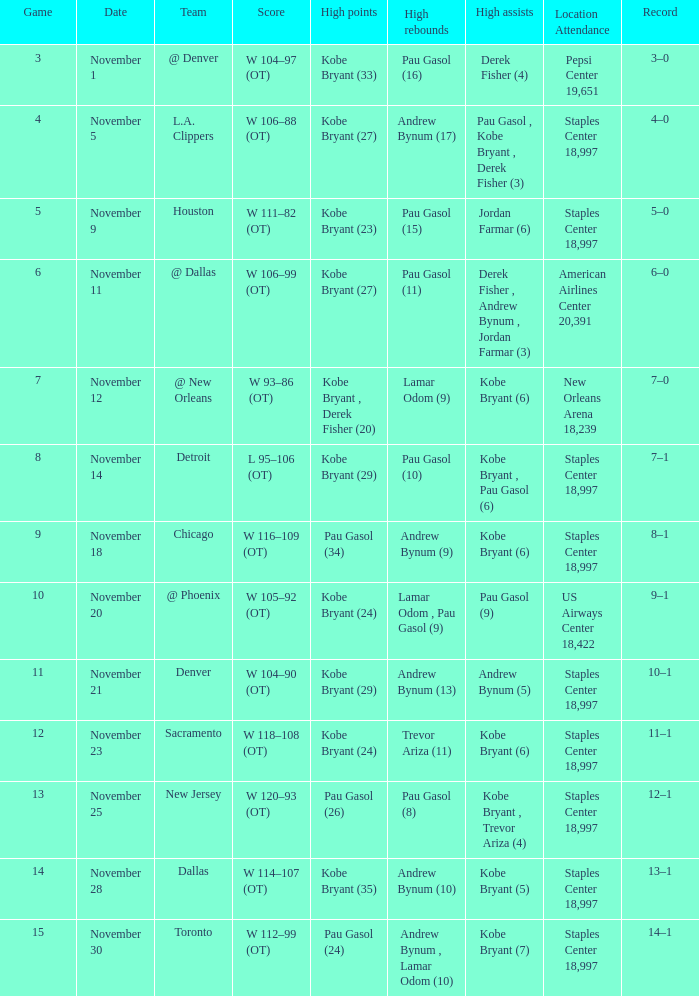What is High Assists, when High Points is "Kobe Bryant (27)", and when High Rebounds is "Pau Gasol (11)"? Derek Fisher , Andrew Bynum , Jordan Farmar (3). 